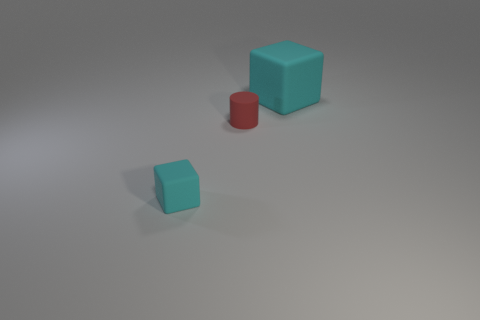Add 3 small matte objects. How many objects exist? 6 Subtract all cylinders. How many objects are left? 2 Subtract 2 cyan cubes. How many objects are left? 1 Subtract all tiny blocks. Subtract all cyan blocks. How many objects are left? 0 Add 2 large blocks. How many large blocks are left? 3 Add 3 small cyan objects. How many small cyan objects exist? 4 